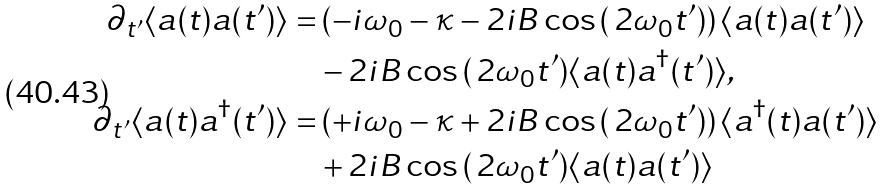<formula> <loc_0><loc_0><loc_500><loc_500>\partial _ { t ^ { \prime } } \langle a ( t ) a ( t ^ { \prime } ) \rangle = & \left ( - i \omega _ { 0 } - \kappa - 2 i B \cos \, ( \, 2 \omega _ { 0 } t ^ { \prime } ) \right ) \langle a ( t ) a ( t ^ { \prime } ) \rangle \\ & - 2 i B \cos \, ( \, 2 \omega _ { 0 } t ^ { \prime } ) \langle a ( t ) a ^ { \dagger } ( t ^ { \prime } ) \rangle , \\ \partial _ { t ^ { \prime } } \langle a ( t ) a ^ { \dagger } ( t ^ { \prime } ) \rangle = & \left ( + i \omega _ { 0 } - \kappa + 2 i B \cos \, ( \, 2 \omega _ { 0 } t ^ { \prime } ) \right ) \langle a ^ { \dagger } ( t ) a ( t ^ { \prime } ) \rangle \\ & + 2 i B \cos \, ( \, 2 \omega _ { 0 } t ^ { \prime } ) \langle a ( t ) a ( t ^ { \prime } ) \rangle</formula> 